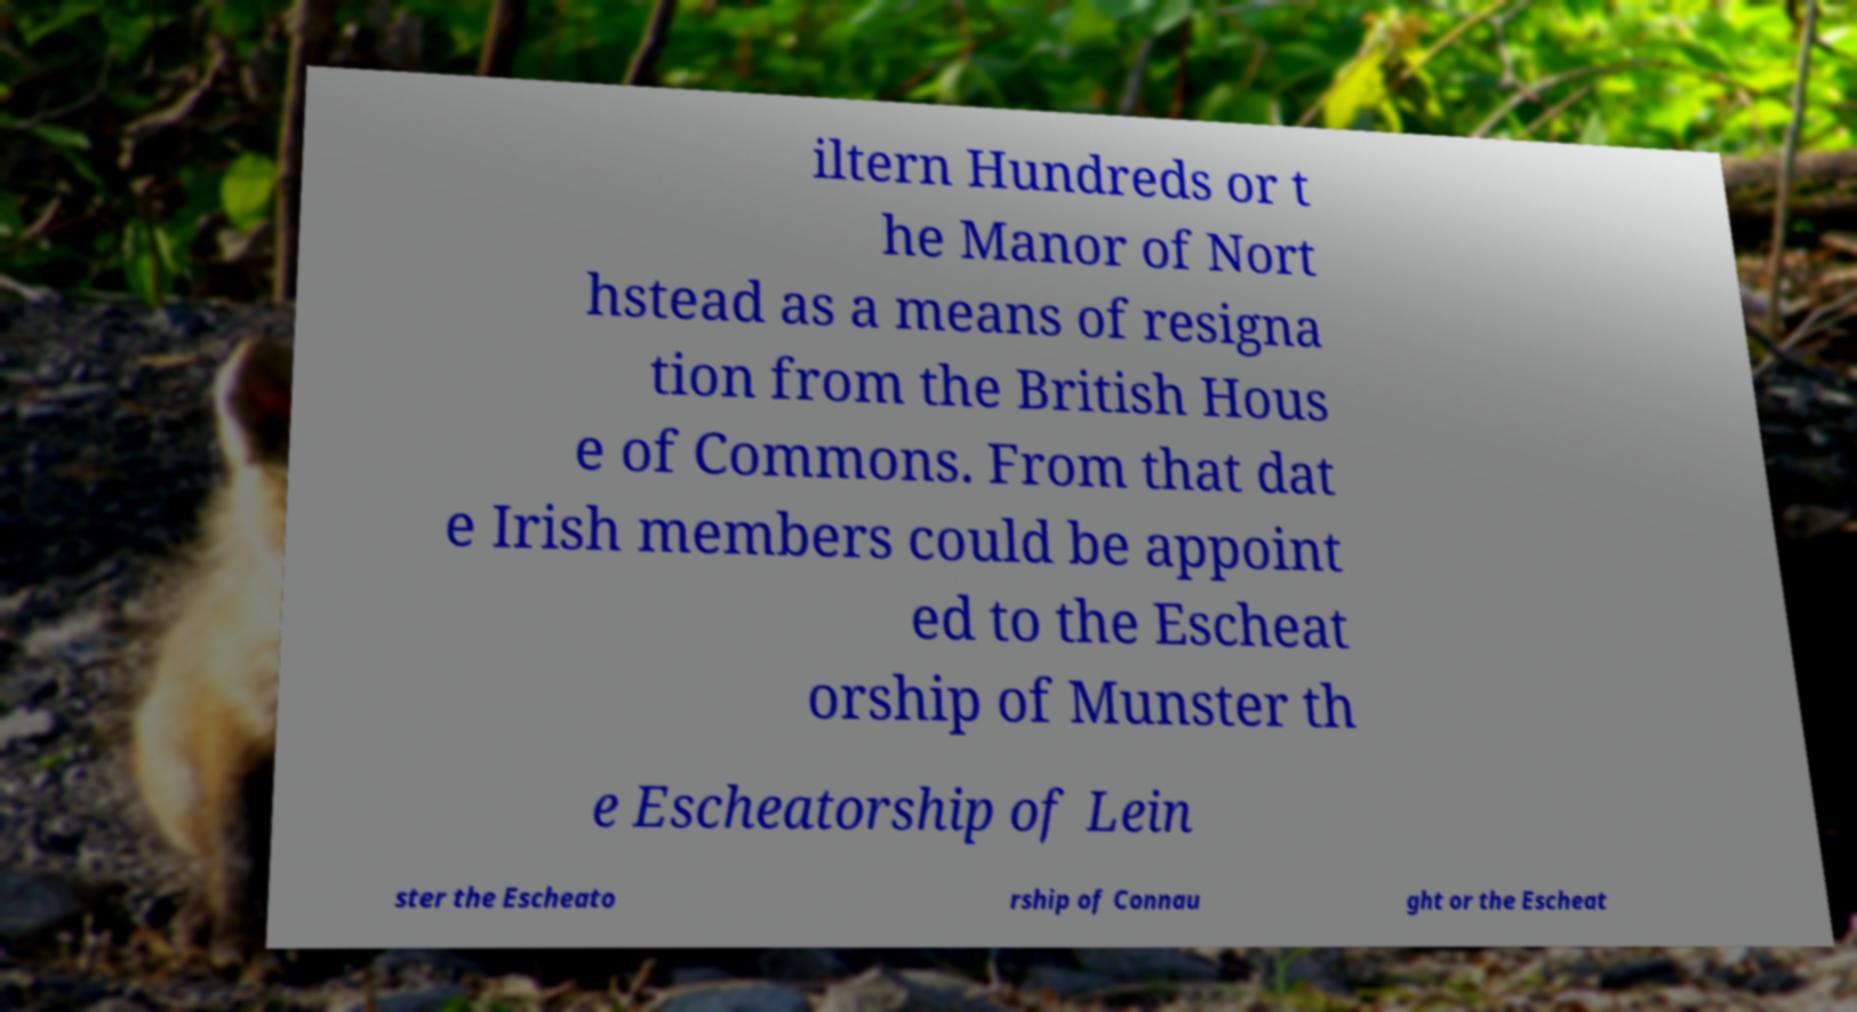There's text embedded in this image that I need extracted. Can you transcribe it verbatim? iltern Hundreds or t he Manor of Nort hstead as a means of resigna tion from the British Hous e of Commons. From that dat e Irish members could be appoint ed to the Escheat orship of Munster th e Escheatorship of Lein ster the Escheato rship of Connau ght or the Escheat 